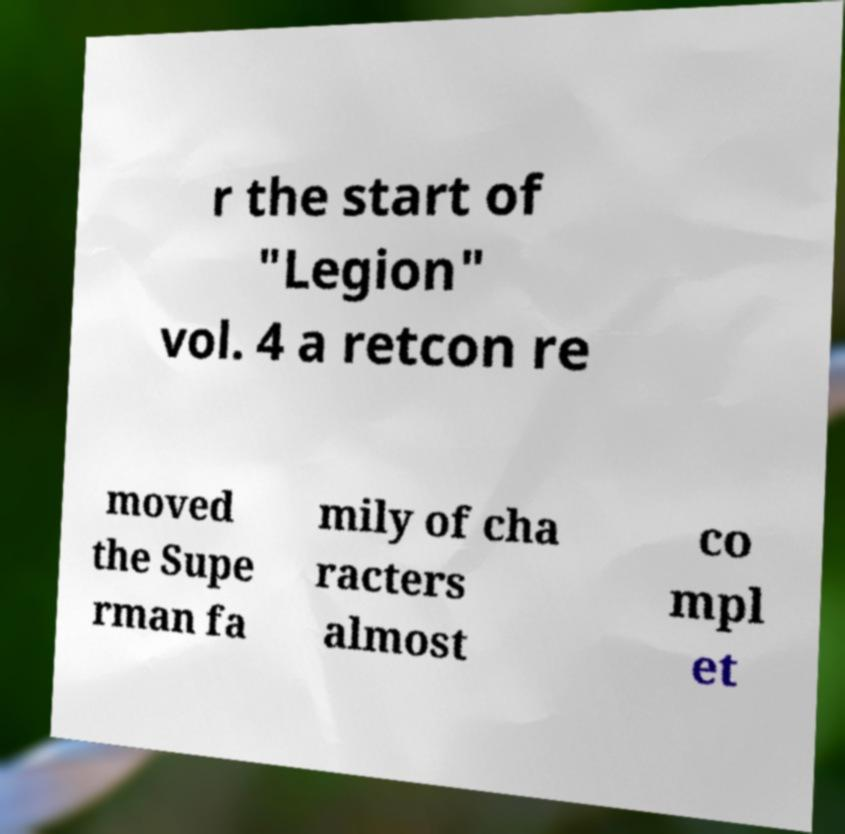What messages or text are displayed in this image? I need them in a readable, typed format. r the start of "Legion" vol. 4 a retcon re moved the Supe rman fa mily of cha racters almost co mpl et 